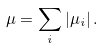Convert formula to latex. <formula><loc_0><loc_0><loc_500><loc_500>\mu = \sum _ { i } | \mu _ { i } | \, .</formula> 